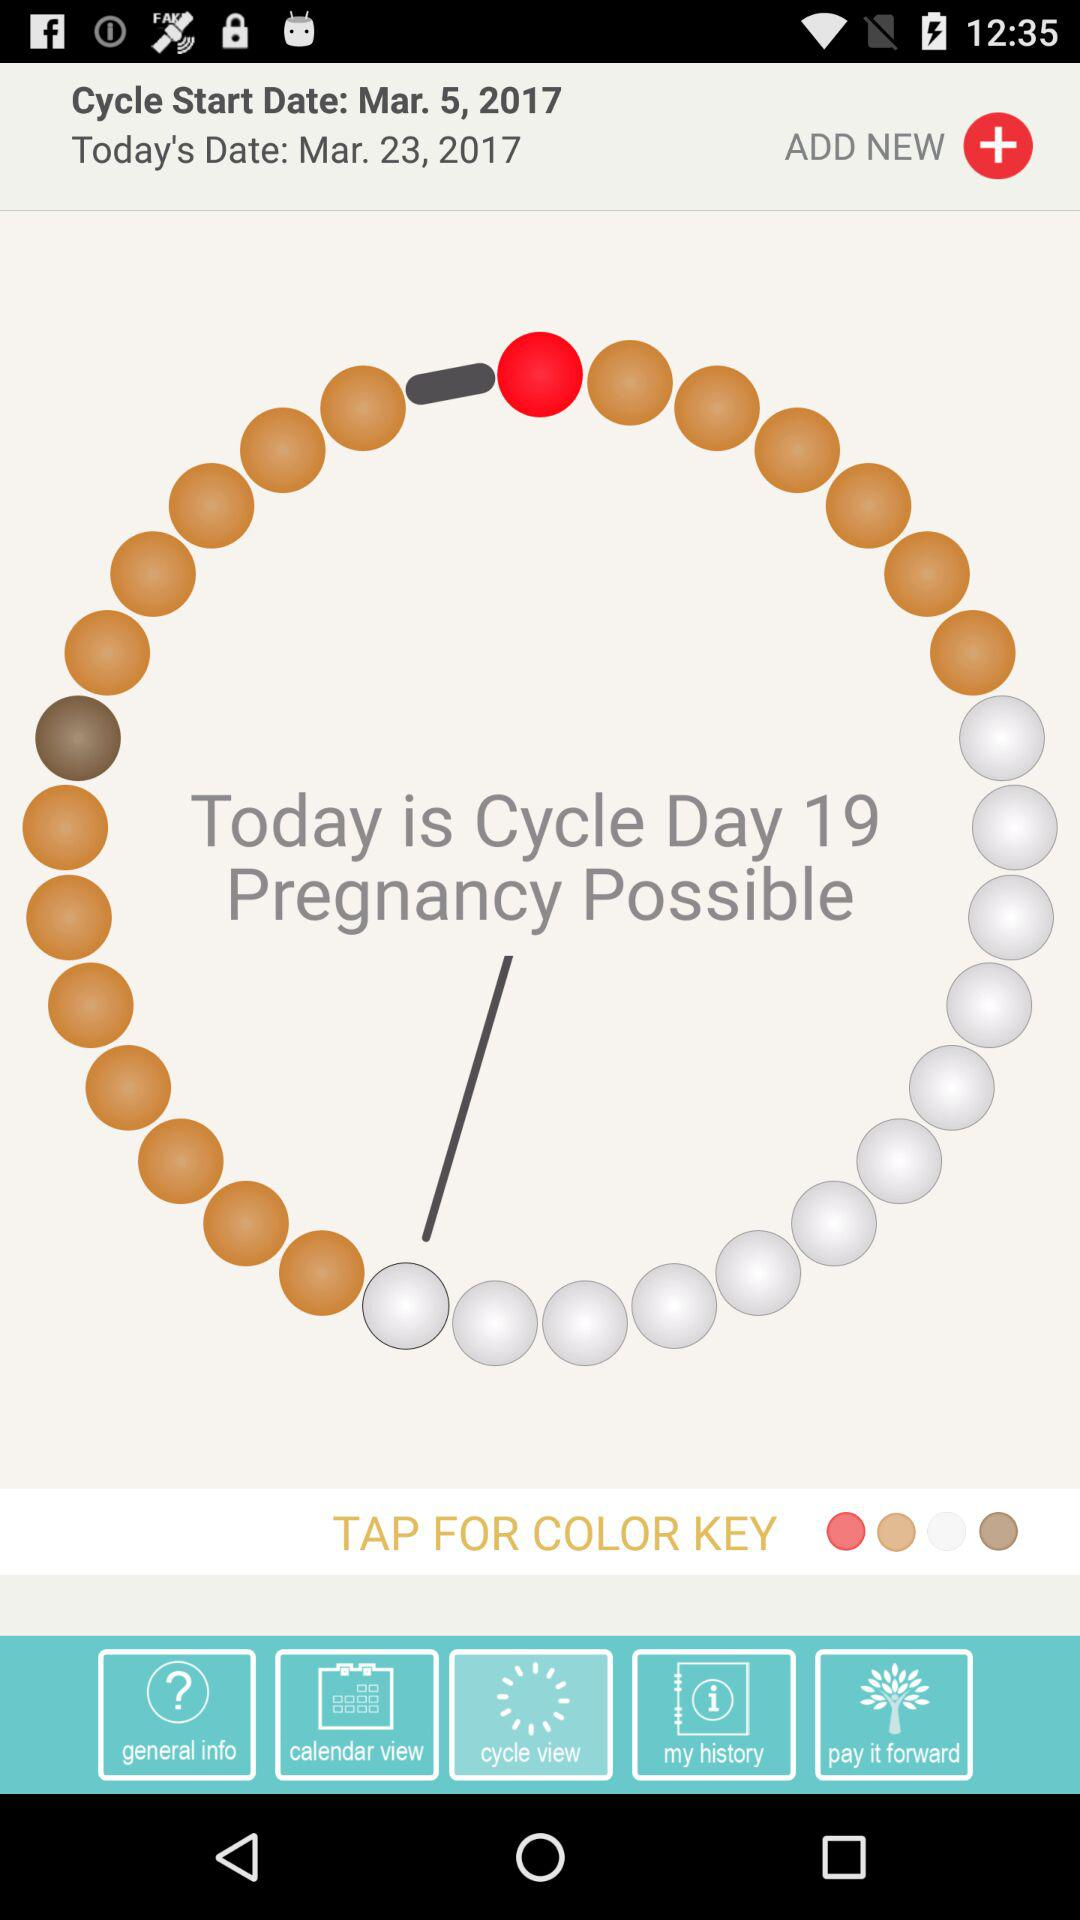What is the date today? The date is March 23, 2017. 